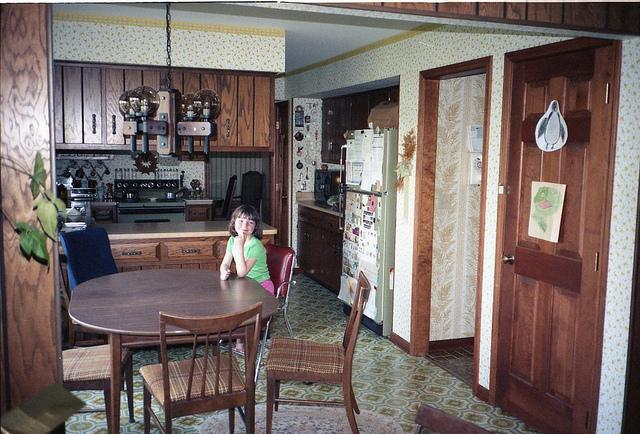In what is the most likely type of structure is this room? Please explain your reasoning. house. This looks like a residential kitchen so this must be a house. 